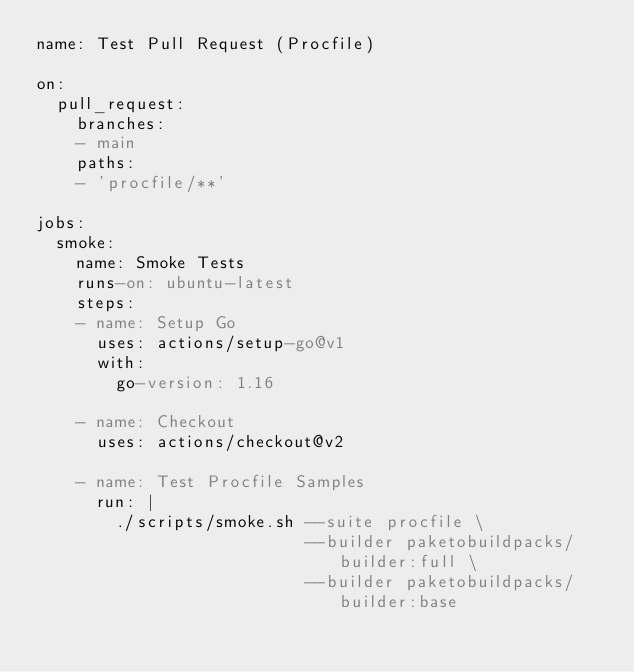<code> <loc_0><loc_0><loc_500><loc_500><_YAML_>name: Test Pull Request (Procfile)

on:
  pull_request:
    branches:
    - main
    paths:
    - 'procfile/**'

jobs:
  smoke:
    name: Smoke Tests
    runs-on: ubuntu-latest
    steps:
    - name: Setup Go
      uses: actions/setup-go@v1
      with:
        go-version: 1.16

    - name: Checkout
      uses: actions/checkout@v2

    - name: Test Procfile Samples
      run: |
        ./scripts/smoke.sh --suite procfile \
                           --builder paketobuildpacks/builder:full \
                           --builder paketobuildpacks/builder:base
</code> 